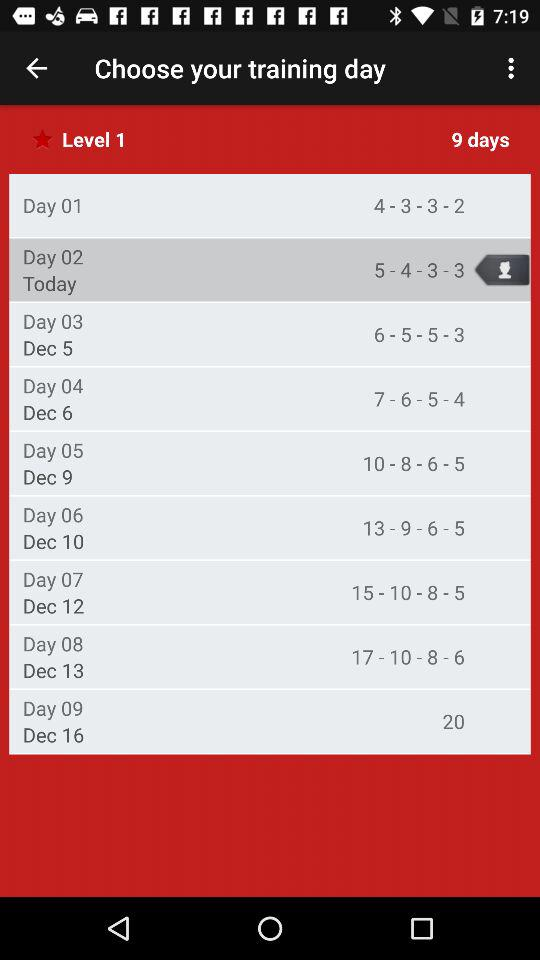Which day of training is today? Today is the 2nd day of training. 